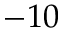<formula> <loc_0><loc_0><loc_500><loc_500>- 1 0</formula> 